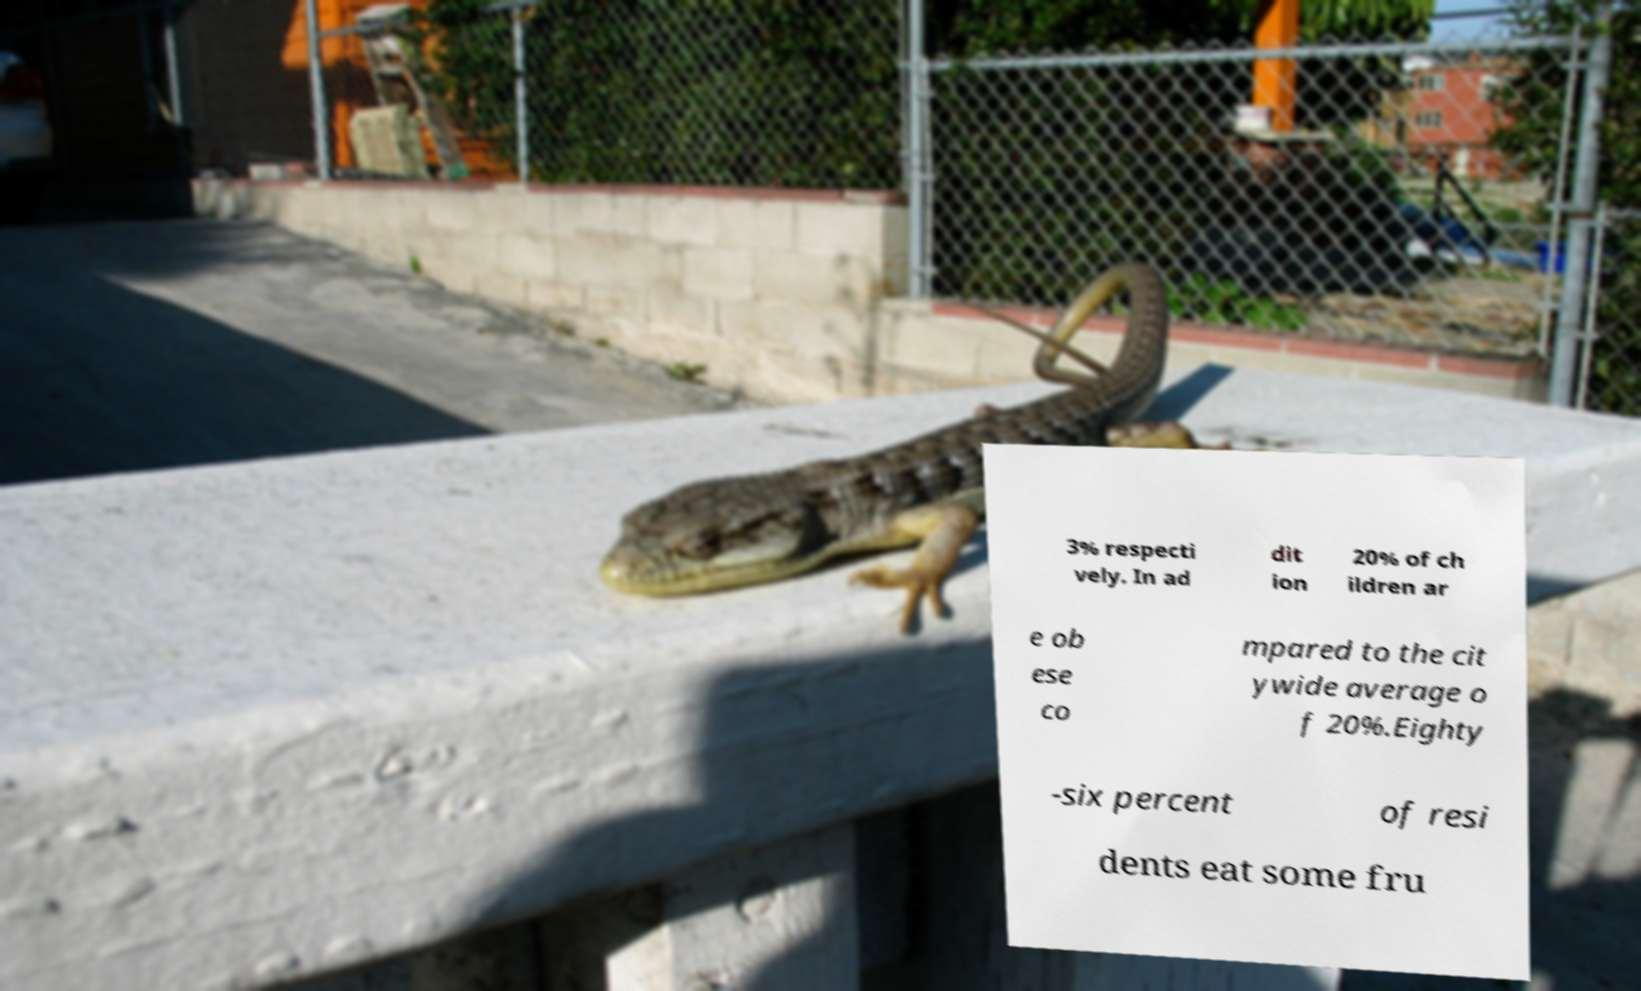Please identify and transcribe the text found in this image. 3% respecti vely. In ad dit ion 20% of ch ildren ar e ob ese co mpared to the cit ywide average o f 20%.Eighty -six percent of resi dents eat some fru 